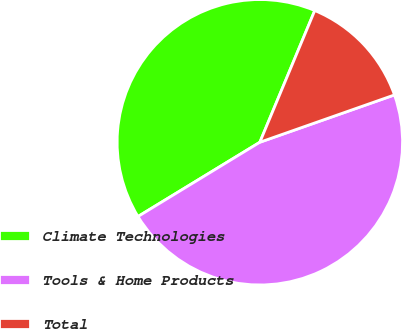Convert chart. <chart><loc_0><loc_0><loc_500><loc_500><pie_chart><fcel>Climate Technologies<fcel>Tools & Home Products<fcel>Total<nl><fcel>40.0%<fcel>46.67%<fcel>13.33%<nl></chart> 